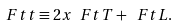<formula> <loc_0><loc_0><loc_500><loc_500>\ F t t \equiv 2 x \ F t T + \ F t L .</formula> 